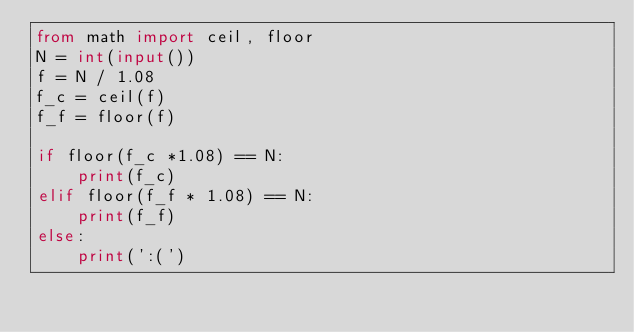<code> <loc_0><loc_0><loc_500><loc_500><_Python_>from math import ceil, floor
N = int(input())
f = N / 1.08
f_c = ceil(f)
f_f = floor(f)

if floor(f_c *1.08) == N:
    print(f_c)
elif floor(f_f * 1.08) == N:
    print(f_f)
else:
    print(':(')</code> 